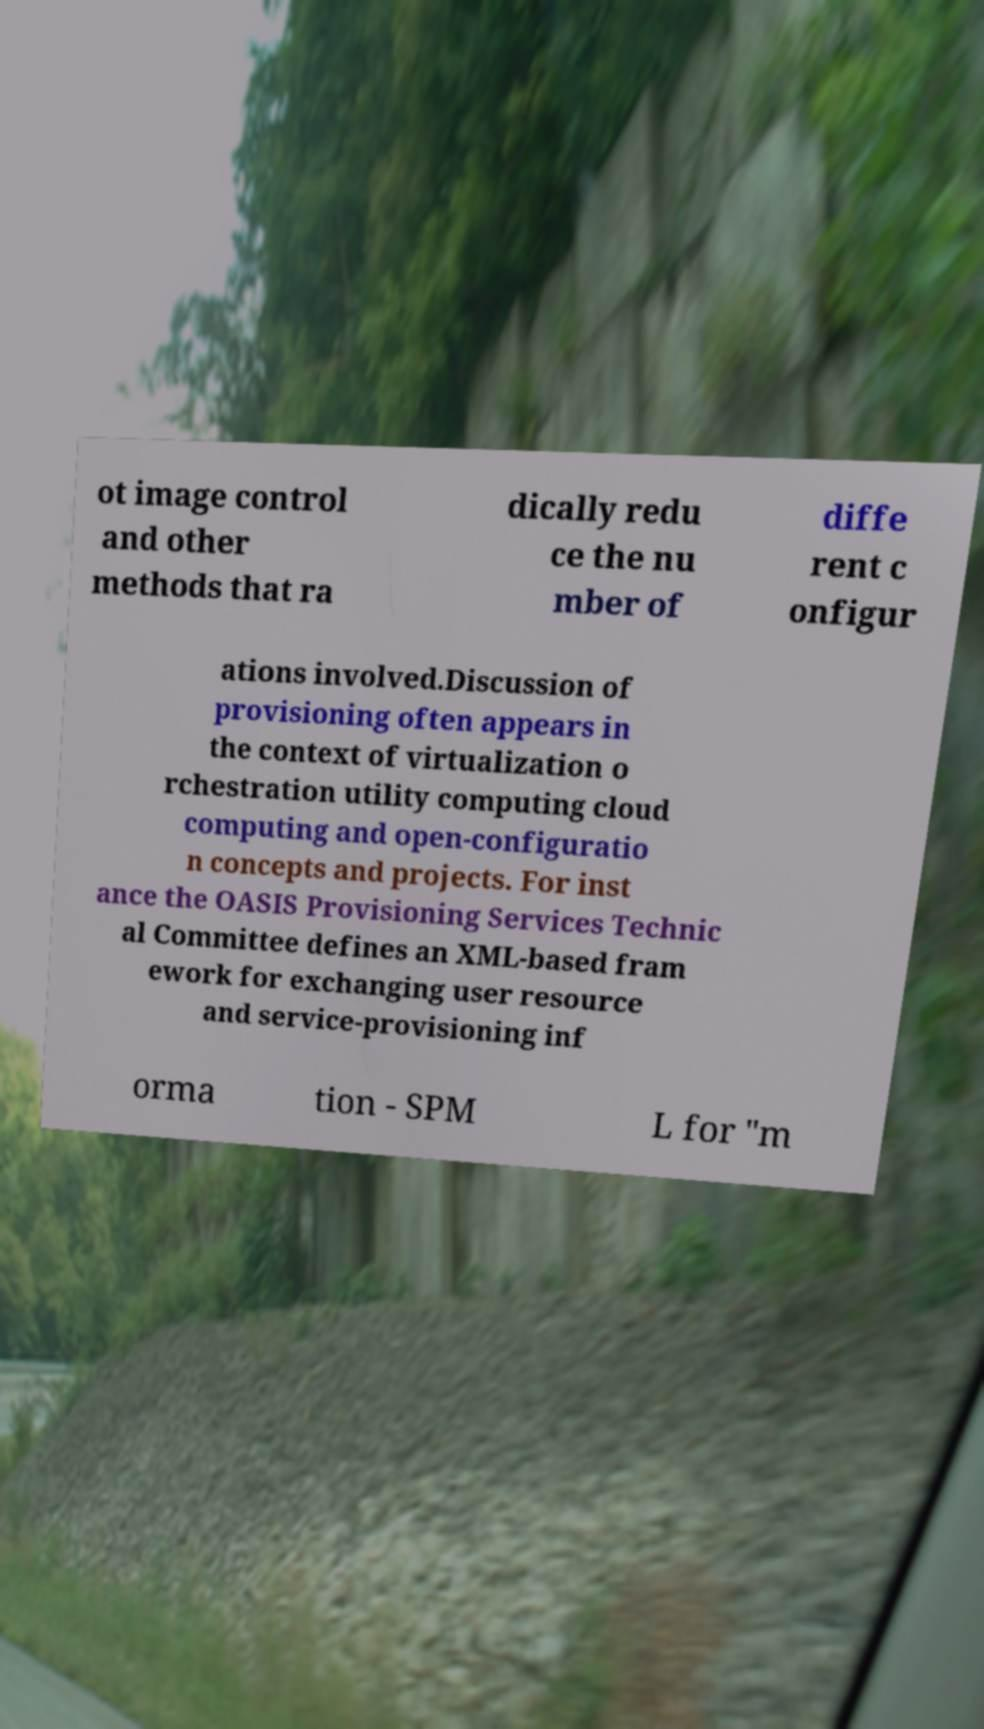What messages or text are displayed in this image? I need them in a readable, typed format. ot image control and other methods that ra dically redu ce the nu mber of diffe rent c onfigur ations involved.Discussion of provisioning often appears in the context of virtualization o rchestration utility computing cloud computing and open-configuratio n concepts and projects. For inst ance the OASIS Provisioning Services Technic al Committee defines an XML-based fram ework for exchanging user resource and service-provisioning inf orma tion - SPM L for "m 